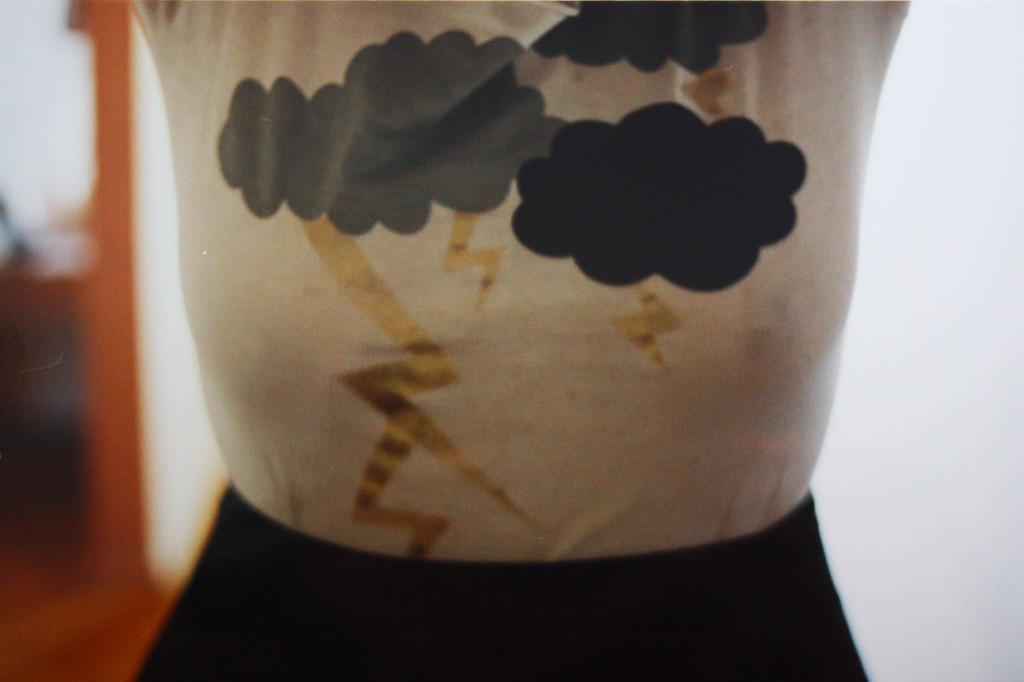What can be seen in the image? There are clothes in the image. What else can be observed in the image? There are objects in the background of the image. How would you describe the clarity of the image? The image is blurry. Is there any rain visible in the image? There is no rain present in the image. What type of teeth can be seen in the image? There are no teeth visible in the image. 